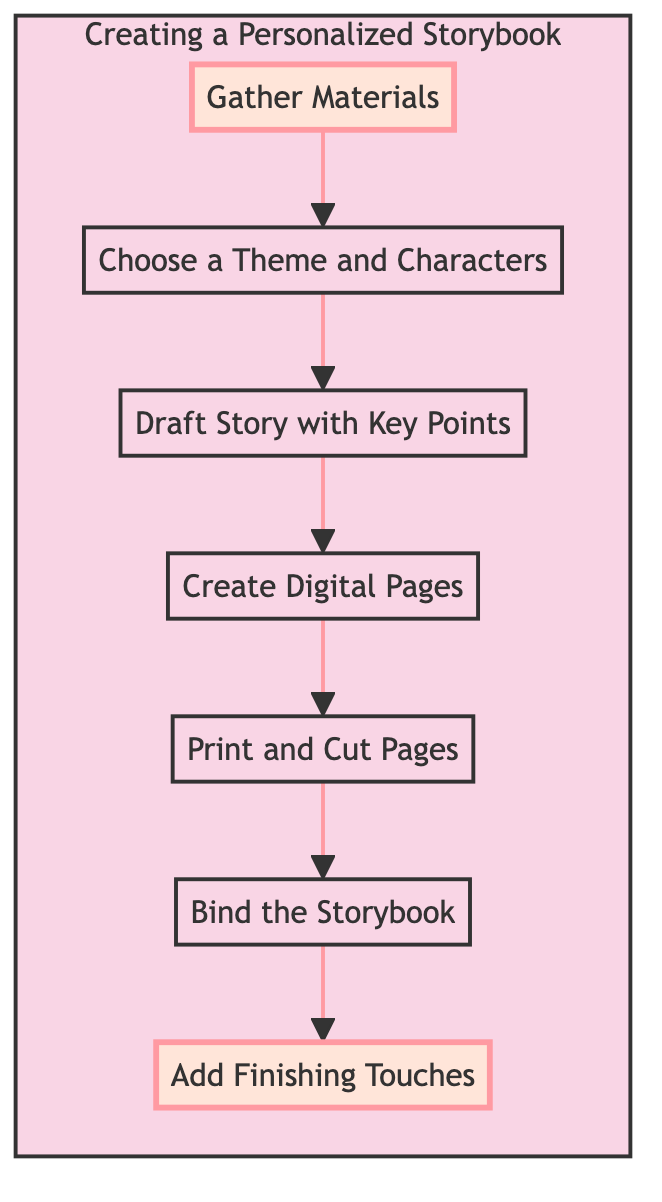What is the first step in creating a personalized storybook? The first step is represented by node A, which is "Gather Materials." It is the starting point of the flowchart, indicating that you need to collect necessary supplies before proceeding further.
Answer: Gather Materials How many steps are in the process? By counting the nodes in the flowchart from "Gather Materials" to the final step "Add Finishing Touches," we find there are seven steps in total.
Answer: 7 What comes after creating digital pages? The flow indicates that after "Create Digital Pages," the next step is "Print and Cut Pages." This shows the sequential flow of the process.
Answer: Print and Cut Pages What is the last step in this process? The last step, shown at the top of the flowchart, is "Add Finishing Touches." This final step emphasizes the completion of the personalized storybook.
Answer: Add Finishing Touches Which step involves planning the storyline? According to the flowchart, "Draft Story with Key Points" is the step that requires planning the storyline before creating the pages.
Answer: Draft Story with Key Points If a theme and characters are chosen, what is the next action? After "Choose a Theme and Characters," you need to "Draft Story with Key Points." This follows logically as you must outline the story after establishing the theme.
Answer: Draft Story with Key Points What binding options are suggested in the diagram? The process mentions "Bind the Storybook," which does not specify options like stapling or sewing, but implies assembling the pages into book format, indicating various binding methods could be used.
Answer: Binding methods (e.g., stapling, sewing) Which step involves decoration of the pages? The flowchart depicts that "Add Finishing Touches" is the step that focuses on decorating the pages with art supplies, making it a personalization step.
Answer: Add Finishing Touches 